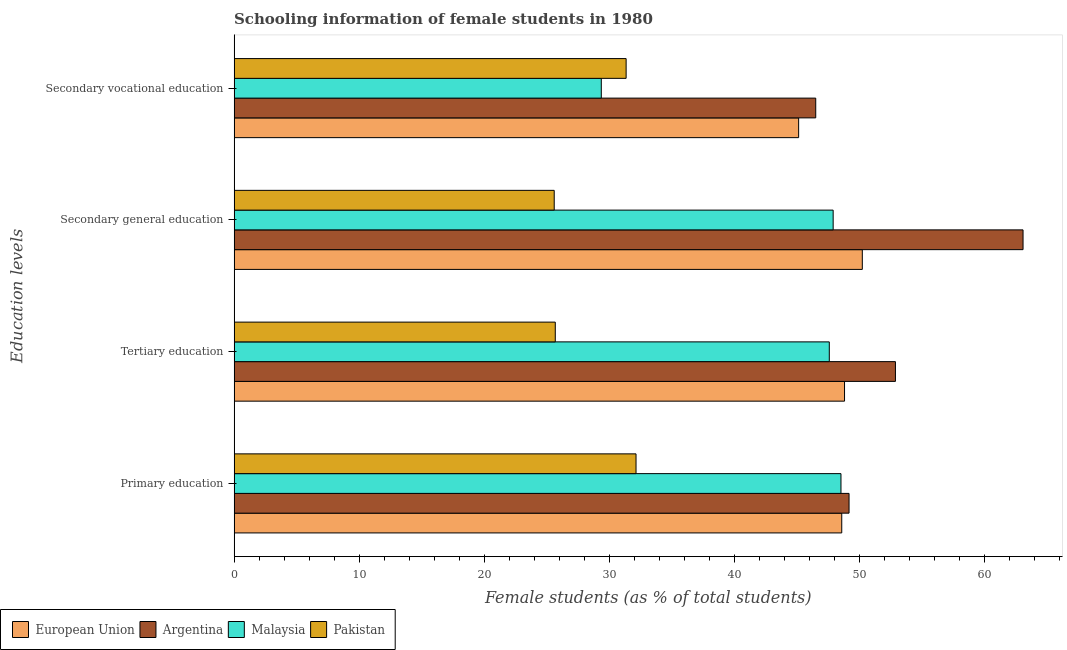How many groups of bars are there?
Offer a very short reply. 4. How many bars are there on the 3rd tick from the top?
Ensure brevity in your answer.  4. How many bars are there on the 3rd tick from the bottom?
Offer a terse response. 4. What is the label of the 3rd group of bars from the top?
Offer a terse response. Tertiary education. What is the percentage of female students in tertiary education in European Union?
Provide a succinct answer. 48.84. Across all countries, what is the maximum percentage of female students in tertiary education?
Provide a short and direct response. 52.91. Across all countries, what is the minimum percentage of female students in secondary vocational education?
Ensure brevity in your answer.  29.38. In which country was the percentage of female students in tertiary education minimum?
Ensure brevity in your answer.  Pakistan. What is the total percentage of female students in tertiary education in the graph?
Provide a succinct answer. 175.07. What is the difference between the percentage of female students in secondary education in Malaysia and that in Argentina?
Your answer should be very brief. -15.19. What is the difference between the percentage of female students in secondary vocational education in Argentina and the percentage of female students in secondary education in European Union?
Make the answer very short. -3.73. What is the average percentage of female students in secondary vocational education per country?
Provide a succinct answer. 38.11. What is the difference between the percentage of female students in primary education and percentage of female students in tertiary education in Argentina?
Provide a succinct answer. -3.71. What is the ratio of the percentage of female students in primary education in Pakistan to that in European Union?
Ensure brevity in your answer.  0.66. Is the percentage of female students in tertiary education in European Union less than that in Argentina?
Offer a terse response. Yes. Is the difference between the percentage of female students in primary education in Argentina and Malaysia greater than the difference between the percentage of female students in secondary education in Argentina and Malaysia?
Ensure brevity in your answer.  No. What is the difference between the highest and the second highest percentage of female students in primary education?
Provide a short and direct response. 0.58. What is the difference between the highest and the lowest percentage of female students in secondary vocational education?
Offer a very short reply. 17.16. Is the sum of the percentage of female students in secondary education in European Union and Pakistan greater than the maximum percentage of female students in secondary vocational education across all countries?
Offer a terse response. Yes. What does the 1st bar from the top in Secondary general education represents?
Your answer should be very brief. Pakistan. What does the 4th bar from the bottom in Primary education represents?
Provide a short and direct response. Pakistan. Is it the case that in every country, the sum of the percentage of female students in primary education and percentage of female students in tertiary education is greater than the percentage of female students in secondary education?
Ensure brevity in your answer.  Yes. What is the difference between two consecutive major ticks on the X-axis?
Make the answer very short. 10. How are the legend labels stacked?
Your response must be concise. Horizontal. What is the title of the graph?
Offer a terse response. Schooling information of female students in 1980. Does "Peru" appear as one of the legend labels in the graph?
Your answer should be compact. No. What is the label or title of the X-axis?
Your answer should be compact. Female students (as % of total students). What is the label or title of the Y-axis?
Your response must be concise. Education levels. What is the Female students (as % of total students) of European Union in Primary education?
Your answer should be compact. 48.62. What is the Female students (as % of total students) of Argentina in Primary education?
Provide a short and direct response. 49.2. What is the Female students (as % of total students) of Malaysia in Primary education?
Provide a short and direct response. 48.55. What is the Female students (as % of total students) of Pakistan in Primary education?
Your response must be concise. 32.16. What is the Female students (as % of total students) of European Union in Tertiary education?
Ensure brevity in your answer.  48.84. What is the Female students (as % of total students) in Argentina in Tertiary education?
Provide a succinct answer. 52.91. What is the Female students (as % of total students) in Malaysia in Tertiary education?
Provide a short and direct response. 47.62. What is the Female students (as % of total students) of Pakistan in Tertiary education?
Your answer should be compact. 25.7. What is the Female students (as % of total students) of European Union in Secondary general education?
Keep it short and to the point. 50.26. What is the Female students (as % of total students) in Argentina in Secondary general education?
Offer a very short reply. 63.12. What is the Female students (as % of total students) of Malaysia in Secondary general education?
Give a very brief answer. 47.93. What is the Female students (as % of total students) in Pakistan in Secondary general education?
Offer a terse response. 25.61. What is the Female students (as % of total students) of European Union in Secondary vocational education?
Ensure brevity in your answer.  45.17. What is the Female students (as % of total students) in Argentina in Secondary vocational education?
Your answer should be compact. 46.53. What is the Female students (as % of total students) in Malaysia in Secondary vocational education?
Ensure brevity in your answer.  29.38. What is the Female students (as % of total students) in Pakistan in Secondary vocational education?
Keep it short and to the point. 31.36. Across all Education levels, what is the maximum Female students (as % of total students) in European Union?
Offer a very short reply. 50.26. Across all Education levels, what is the maximum Female students (as % of total students) in Argentina?
Offer a very short reply. 63.12. Across all Education levels, what is the maximum Female students (as % of total students) in Malaysia?
Provide a succinct answer. 48.55. Across all Education levels, what is the maximum Female students (as % of total students) of Pakistan?
Offer a terse response. 32.16. Across all Education levels, what is the minimum Female students (as % of total students) of European Union?
Offer a very short reply. 45.17. Across all Education levels, what is the minimum Female students (as % of total students) of Argentina?
Keep it short and to the point. 46.53. Across all Education levels, what is the minimum Female students (as % of total students) of Malaysia?
Offer a terse response. 29.38. Across all Education levels, what is the minimum Female students (as % of total students) in Pakistan?
Ensure brevity in your answer.  25.61. What is the total Female students (as % of total students) in European Union in the graph?
Your answer should be very brief. 192.88. What is the total Female students (as % of total students) in Argentina in the graph?
Provide a succinct answer. 211.77. What is the total Female students (as % of total students) in Malaysia in the graph?
Offer a terse response. 173.48. What is the total Female students (as % of total students) of Pakistan in the graph?
Your answer should be compact. 114.83. What is the difference between the Female students (as % of total students) of European Union in Primary education and that in Tertiary education?
Give a very brief answer. -0.22. What is the difference between the Female students (as % of total students) of Argentina in Primary education and that in Tertiary education?
Your answer should be very brief. -3.71. What is the difference between the Female students (as % of total students) in Malaysia in Primary education and that in Tertiary education?
Your response must be concise. 0.93. What is the difference between the Female students (as % of total students) of Pakistan in Primary education and that in Tertiary education?
Ensure brevity in your answer.  6.46. What is the difference between the Female students (as % of total students) of European Union in Primary education and that in Secondary general education?
Offer a terse response. -1.64. What is the difference between the Female students (as % of total students) in Argentina in Primary education and that in Secondary general education?
Keep it short and to the point. -13.92. What is the difference between the Female students (as % of total students) in Malaysia in Primary education and that in Secondary general education?
Keep it short and to the point. 0.62. What is the difference between the Female students (as % of total students) in Pakistan in Primary education and that in Secondary general education?
Provide a short and direct response. 6.55. What is the difference between the Female students (as % of total students) of European Union in Primary education and that in Secondary vocational education?
Provide a succinct answer. 3.45. What is the difference between the Female students (as % of total students) of Argentina in Primary education and that in Secondary vocational education?
Offer a terse response. 2.67. What is the difference between the Female students (as % of total students) of Malaysia in Primary education and that in Secondary vocational education?
Give a very brief answer. 19.18. What is the difference between the Female students (as % of total students) in Pakistan in Primary education and that in Secondary vocational education?
Ensure brevity in your answer.  0.79. What is the difference between the Female students (as % of total students) of European Union in Tertiary education and that in Secondary general education?
Offer a terse response. -1.42. What is the difference between the Female students (as % of total students) in Argentina in Tertiary education and that in Secondary general education?
Offer a very short reply. -10.21. What is the difference between the Female students (as % of total students) of Malaysia in Tertiary education and that in Secondary general education?
Ensure brevity in your answer.  -0.31. What is the difference between the Female students (as % of total students) of Pakistan in Tertiary education and that in Secondary general education?
Your response must be concise. 0.09. What is the difference between the Female students (as % of total students) in European Union in Tertiary education and that in Secondary vocational education?
Give a very brief answer. 3.67. What is the difference between the Female students (as % of total students) of Argentina in Tertiary education and that in Secondary vocational education?
Provide a succinct answer. 6.38. What is the difference between the Female students (as % of total students) in Malaysia in Tertiary education and that in Secondary vocational education?
Give a very brief answer. 18.24. What is the difference between the Female students (as % of total students) in Pakistan in Tertiary education and that in Secondary vocational education?
Your answer should be very brief. -5.67. What is the difference between the Female students (as % of total students) of European Union in Secondary general education and that in Secondary vocational education?
Provide a short and direct response. 5.09. What is the difference between the Female students (as % of total students) in Argentina in Secondary general education and that in Secondary vocational education?
Keep it short and to the point. 16.59. What is the difference between the Female students (as % of total students) of Malaysia in Secondary general education and that in Secondary vocational education?
Offer a very short reply. 18.55. What is the difference between the Female students (as % of total students) in Pakistan in Secondary general education and that in Secondary vocational education?
Provide a short and direct response. -5.75. What is the difference between the Female students (as % of total students) in European Union in Primary education and the Female students (as % of total students) in Argentina in Tertiary education?
Keep it short and to the point. -4.3. What is the difference between the Female students (as % of total students) in European Union in Primary education and the Female students (as % of total students) in Pakistan in Tertiary education?
Your response must be concise. 22.92. What is the difference between the Female students (as % of total students) of Argentina in Primary education and the Female students (as % of total students) of Malaysia in Tertiary education?
Offer a very short reply. 1.58. What is the difference between the Female students (as % of total students) of Argentina in Primary education and the Female students (as % of total students) of Pakistan in Tertiary education?
Make the answer very short. 23.5. What is the difference between the Female students (as % of total students) of Malaysia in Primary education and the Female students (as % of total students) of Pakistan in Tertiary education?
Ensure brevity in your answer.  22.86. What is the difference between the Female students (as % of total students) of European Union in Primary education and the Female students (as % of total students) of Argentina in Secondary general education?
Give a very brief answer. -14.51. What is the difference between the Female students (as % of total students) in European Union in Primary education and the Female students (as % of total students) in Malaysia in Secondary general education?
Your response must be concise. 0.69. What is the difference between the Female students (as % of total students) of European Union in Primary education and the Female students (as % of total students) of Pakistan in Secondary general education?
Your answer should be compact. 23.01. What is the difference between the Female students (as % of total students) in Argentina in Primary education and the Female students (as % of total students) in Malaysia in Secondary general education?
Your answer should be very brief. 1.27. What is the difference between the Female students (as % of total students) of Argentina in Primary education and the Female students (as % of total students) of Pakistan in Secondary general education?
Provide a short and direct response. 23.59. What is the difference between the Female students (as % of total students) in Malaysia in Primary education and the Female students (as % of total students) in Pakistan in Secondary general education?
Provide a succinct answer. 22.94. What is the difference between the Female students (as % of total students) of European Union in Primary education and the Female students (as % of total students) of Argentina in Secondary vocational education?
Offer a very short reply. 2.08. What is the difference between the Female students (as % of total students) in European Union in Primary education and the Female students (as % of total students) in Malaysia in Secondary vocational education?
Provide a succinct answer. 19.24. What is the difference between the Female students (as % of total students) in European Union in Primary education and the Female students (as % of total students) in Pakistan in Secondary vocational education?
Offer a terse response. 17.25. What is the difference between the Female students (as % of total students) of Argentina in Primary education and the Female students (as % of total students) of Malaysia in Secondary vocational education?
Your response must be concise. 19.82. What is the difference between the Female students (as % of total students) of Argentina in Primary education and the Female students (as % of total students) of Pakistan in Secondary vocational education?
Ensure brevity in your answer.  17.84. What is the difference between the Female students (as % of total students) in Malaysia in Primary education and the Female students (as % of total students) in Pakistan in Secondary vocational education?
Keep it short and to the point. 17.19. What is the difference between the Female students (as % of total students) of European Union in Tertiary education and the Female students (as % of total students) of Argentina in Secondary general education?
Give a very brief answer. -14.28. What is the difference between the Female students (as % of total students) of European Union in Tertiary education and the Female students (as % of total students) of Malaysia in Secondary general education?
Give a very brief answer. 0.91. What is the difference between the Female students (as % of total students) of European Union in Tertiary education and the Female students (as % of total students) of Pakistan in Secondary general education?
Offer a terse response. 23.23. What is the difference between the Female students (as % of total students) of Argentina in Tertiary education and the Female students (as % of total students) of Malaysia in Secondary general education?
Offer a terse response. 4.98. What is the difference between the Female students (as % of total students) of Argentina in Tertiary education and the Female students (as % of total students) of Pakistan in Secondary general education?
Offer a terse response. 27.3. What is the difference between the Female students (as % of total students) in Malaysia in Tertiary education and the Female students (as % of total students) in Pakistan in Secondary general education?
Ensure brevity in your answer.  22.01. What is the difference between the Female students (as % of total students) in European Union in Tertiary education and the Female students (as % of total students) in Argentina in Secondary vocational education?
Your response must be concise. 2.3. What is the difference between the Female students (as % of total students) in European Union in Tertiary education and the Female students (as % of total students) in Malaysia in Secondary vocational education?
Offer a very short reply. 19.46. What is the difference between the Female students (as % of total students) in European Union in Tertiary education and the Female students (as % of total students) in Pakistan in Secondary vocational education?
Your answer should be very brief. 17.47. What is the difference between the Female students (as % of total students) of Argentina in Tertiary education and the Female students (as % of total students) of Malaysia in Secondary vocational education?
Your answer should be compact. 23.53. What is the difference between the Female students (as % of total students) in Argentina in Tertiary education and the Female students (as % of total students) in Pakistan in Secondary vocational education?
Your response must be concise. 21.55. What is the difference between the Female students (as % of total students) of Malaysia in Tertiary education and the Female students (as % of total students) of Pakistan in Secondary vocational education?
Provide a succinct answer. 16.26. What is the difference between the Female students (as % of total students) in European Union in Secondary general education and the Female students (as % of total students) in Argentina in Secondary vocational education?
Give a very brief answer. 3.73. What is the difference between the Female students (as % of total students) of European Union in Secondary general education and the Female students (as % of total students) of Malaysia in Secondary vocational education?
Provide a short and direct response. 20.88. What is the difference between the Female students (as % of total students) of European Union in Secondary general education and the Female students (as % of total students) of Pakistan in Secondary vocational education?
Your answer should be compact. 18.9. What is the difference between the Female students (as % of total students) of Argentina in Secondary general education and the Female students (as % of total students) of Malaysia in Secondary vocational education?
Provide a short and direct response. 33.74. What is the difference between the Female students (as % of total students) in Argentina in Secondary general education and the Female students (as % of total students) in Pakistan in Secondary vocational education?
Your answer should be very brief. 31.76. What is the difference between the Female students (as % of total students) of Malaysia in Secondary general education and the Female students (as % of total students) of Pakistan in Secondary vocational education?
Make the answer very short. 16.56. What is the average Female students (as % of total students) in European Union per Education levels?
Give a very brief answer. 48.22. What is the average Female students (as % of total students) of Argentina per Education levels?
Keep it short and to the point. 52.94. What is the average Female students (as % of total students) of Malaysia per Education levels?
Provide a short and direct response. 43.37. What is the average Female students (as % of total students) of Pakistan per Education levels?
Keep it short and to the point. 28.71. What is the difference between the Female students (as % of total students) of European Union and Female students (as % of total students) of Argentina in Primary education?
Keep it short and to the point. -0.58. What is the difference between the Female students (as % of total students) of European Union and Female students (as % of total students) of Malaysia in Primary education?
Provide a short and direct response. 0.06. What is the difference between the Female students (as % of total students) of European Union and Female students (as % of total students) of Pakistan in Primary education?
Make the answer very short. 16.46. What is the difference between the Female students (as % of total students) of Argentina and Female students (as % of total students) of Malaysia in Primary education?
Your answer should be compact. 0.65. What is the difference between the Female students (as % of total students) of Argentina and Female students (as % of total students) of Pakistan in Primary education?
Offer a very short reply. 17.04. What is the difference between the Female students (as % of total students) in Malaysia and Female students (as % of total students) in Pakistan in Primary education?
Ensure brevity in your answer.  16.4. What is the difference between the Female students (as % of total students) of European Union and Female students (as % of total students) of Argentina in Tertiary education?
Your response must be concise. -4.07. What is the difference between the Female students (as % of total students) in European Union and Female students (as % of total students) in Malaysia in Tertiary education?
Offer a very short reply. 1.22. What is the difference between the Female students (as % of total students) in European Union and Female students (as % of total students) in Pakistan in Tertiary education?
Your answer should be compact. 23.14. What is the difference between the Female students (as % of total students) of Argentina and Female students (as % of total students) of Malaysia in Tertiary education?
Ensure brevity in your answer.  5.29. What is the difference between the Female students (as % of total students) in Argentina and Female students (as % of total students) in Pakistan in Tertiary education?
Give a very brief answer. 27.22. What is the difference between the Female students (as % of total students) of Malaysia and Female students (as % of total students) of Pakistan in Tertiary education?
Provide a succinct answer. 21.92. What is the difference between the Female students (as % of total students) of European Union and Female students (as % of total students) of Argentina in Secondary general education?
Make the answer very short. -12.86. What is the difference between the Female students (as % of total students) of European Union and Female students (as % of total students) of Malaysia in Secondary general education?
Your response must be concise. 2.33. What is the difference between the Female students (as % of total students) of European Union and Female students (as % of total students) of Pakistan in Secondary general education?
Offer a very short reply. 24.65. What is the difference between the Female students (as % of total students) of Argentina and Female students (as % of total students) of Malaysia in Secondary general education?
Give a very brief answer. 15.19. What is the difference between the Female students (as % of total students) of Argentina and Female students (as % of total students) of Pakistan in Secondary general education?
Keep it short and to the point. 37.51. What is the difference between the Female students (as % of total students) of Malaysia and Female students (as % of total students) of Pakistan in Secondary general education?
Make the answer very short. 22.32. What is the difference between the Female students (as % of total students) in European Union and Female students (as % of total students) in Argentina in Secondary vocational education?
Your answer should be compact. -1.37. What is the difference between the Female students (as % of total students) of European Union and Female students (as % of total students) of Malaysia in Secondary vocational education?
Your answer should be compact. 15.79. What is the difference between the Female students (as % of total students) of European Union and Female students (as % of total students) of Pakistan in Secondary vocational education?
Give a very brief answer. 13.8. What is the difference between the Female students (as % of total students) of Argentina and Female students (as % of total students) of Malaysia in Secondary vocational education?
Ensure brevity in your answer.  17.16. What is the difference between the Female students (as % of total students) in Argentina and Female students (as % of total students) in Pakistan in Secondary vocational education?
Keep it short and to the point. 15.17. What is the difference between the Female students (as % of total students) of Malaysia and Female students (as % of total students) of Pakistan in Secondary vocational education?
Make the answer very short. -1.99. What is the ratio of the Female students (as % of total students) in Argentina in Primary education to that in Tertiary education?
Ensure brevity in your answer.  0.93. What is the ratio of the Female students (as % of total students) in Malaysia in Primary education to that in Tertiary education?
Offer a very short reply. 1.02. What is the ratio of the Female students (as % of total students) in Pakistan in Primary education to that in Tertiary education?
Provide a succinct answer. 1.25. What is the ratio of the Female students (as % of total students) of European Union in Primary education to that in Secondary general education?
Keep it short and to the point. 0.97. What is the ratio of the Female students (as % of total students) of Argentina in Primary education to that in Secondary general education?
Your answer should be very brief. 0.78. What is the ratio of the Female students (as % of total students) of Malaysia in Primary education to that in Secondary general education?
Offer a terse response. 1.01. What is the ratio of the Female students (as % of total students) of Pakistan in Primary education to that in Secondary general education?
Your answer should be very brief. 1.26. What is the ratio of the Female students (as % of total students) of European Union in Primary education to that in Secondary vocational education?
Provide a short and direct response. 1.08. What is the ratio of the Female students (as % of total students) of Argentina in Primary education to that in Secondary vocational education?
Keep it short and to the point. 1.06. What is the ratio of the Female students (as % of total students) of Malaysia in Primary education to that in Secondary vocational education?
Offer a terse response. 1.65. What is the ratio of the Female students (as % of total students) of Pakistan in Primary education to that in Secondary vocational education?
Your answer should be compact. 1.03. What is the ratio of the Female students (as % of total students) of European Union in Tertiary education to that in Secondary general education?
Provide a succinct answer. 0.97. What is the ratio of the Female students (as % of total students) of Argentina in Tertiary education to that in Secondary general education?
Your answer should be very brief. 0.84. What is the ratio of the Female students (as % of total students) in Malaysia in Tertiary education to that in Secondary general education?
Offer a terse response. 0.99. What is the ratio of the Female students (as % of total students) of Pakistan in Tertiary education to that in Secondary general education?
Your response must be concise. 1. What is the ratio of the Female students (as % of total students) of European Union in Tertiary education to that in Secondary vocational education?
Offer a very short reply. 1.08. What is the ratio of the Female students (as % of total students) of Argentina in Tertiary education to that in Secondary vocational education?
Your response must be concise. 1.14. What is the ratio of the Female students (as % of total students) in Malaysia in Tertiary education to that in Secondary vocational education?
Offer a very short reply. 1.62. What is the ratio of the Female students (as % of total students) of Pakistan in Tertiary education to that in Secondary vocational education?
Your answer should be compact. 0.82. What is the ratio of the Female students (as % of total students) of European Union in Secondary general education to that in Secondary vocational education?
Your answer should be very brief. 1.11. What is the ratio of the Female students (as % of total students) of Argentina in Secondary general education to that in Secondary vocational education?
Provide a short and direct response. 1.36. What is the ratio of the Female students (as % of total students) in Malaysia in Secondary general education to that in Secondary vocational education?
Provide a short and direct response. 1.63. What is the ratio of the Female students (as % of total students) in Pakistan in Secondary general education to that in Secondary vocational education?
Give a very brief answer. 0.82. What is the difference between the highest and the second highest Female students (as % of total students) of European Union?
Make the answer very short. 1.42. What is the difference between the highest and the second highest Female students (as % of total students) in Argentina?
Provide a succinct answer. 10.21. What is the difference between the highest and the second highest Female students (as % of total students) in Malaysia?
Your answer should be very brief. 0.62. What is the difference between the highest and the second highest Female students (as % of total students) of Pakistan?
Offer a very short reply. 0.79. What is the difference between the highest and the lowest Female students (as % of total students) of European Union?
Give a very brief answer. 5.09. What is the difference between the highest and the lowest Female students (as % of total students) of Argentina?
Provide a short and direct response. 16.59. What is the difference between the highest and the lowest Female students (as % of total students) in Malaysia?
Offer a very short reply. 19.18. What is the difference between the highest and the lowest Female students (as % of total students) in Pakistan?
Your answer should be very brief. 6.55. 